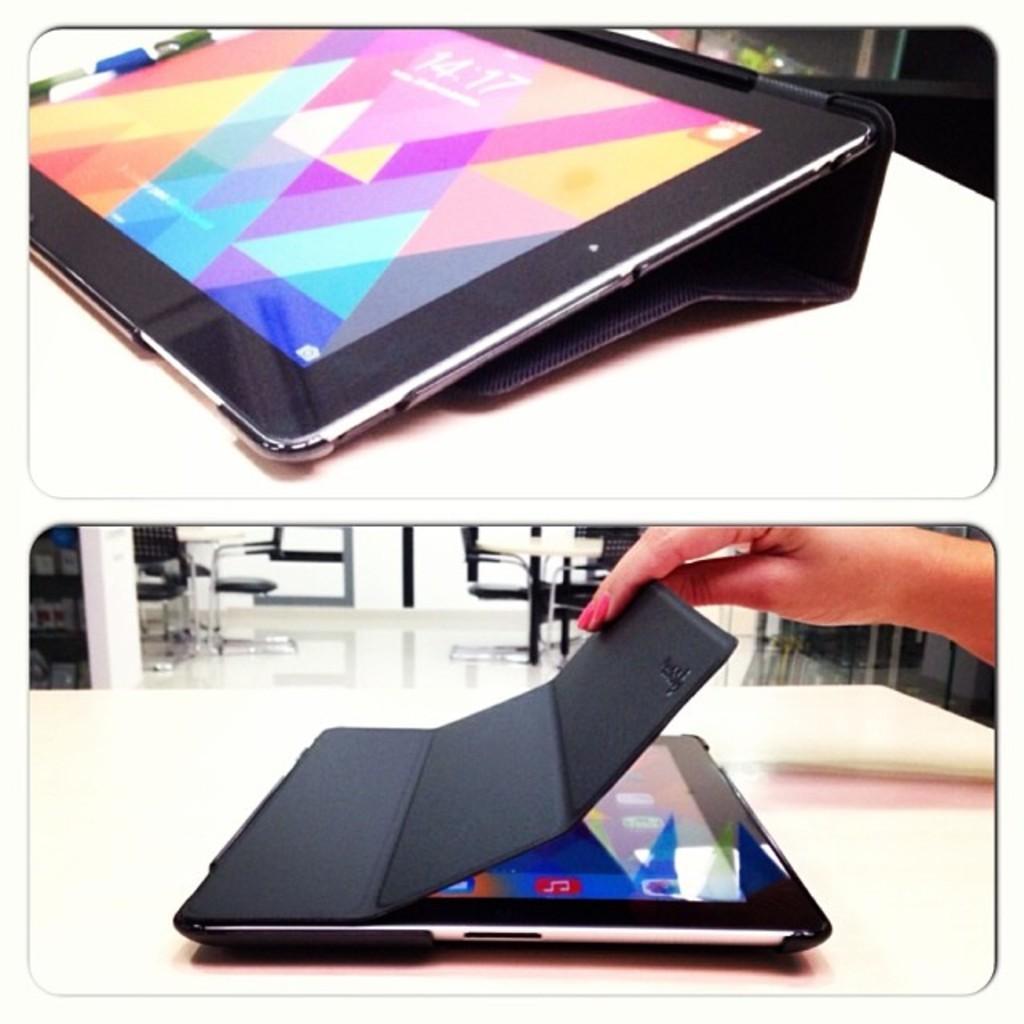How would you summarize this image in a sentence or two? In the picture we can see two photographs with two tablets and a person hand touching it. 